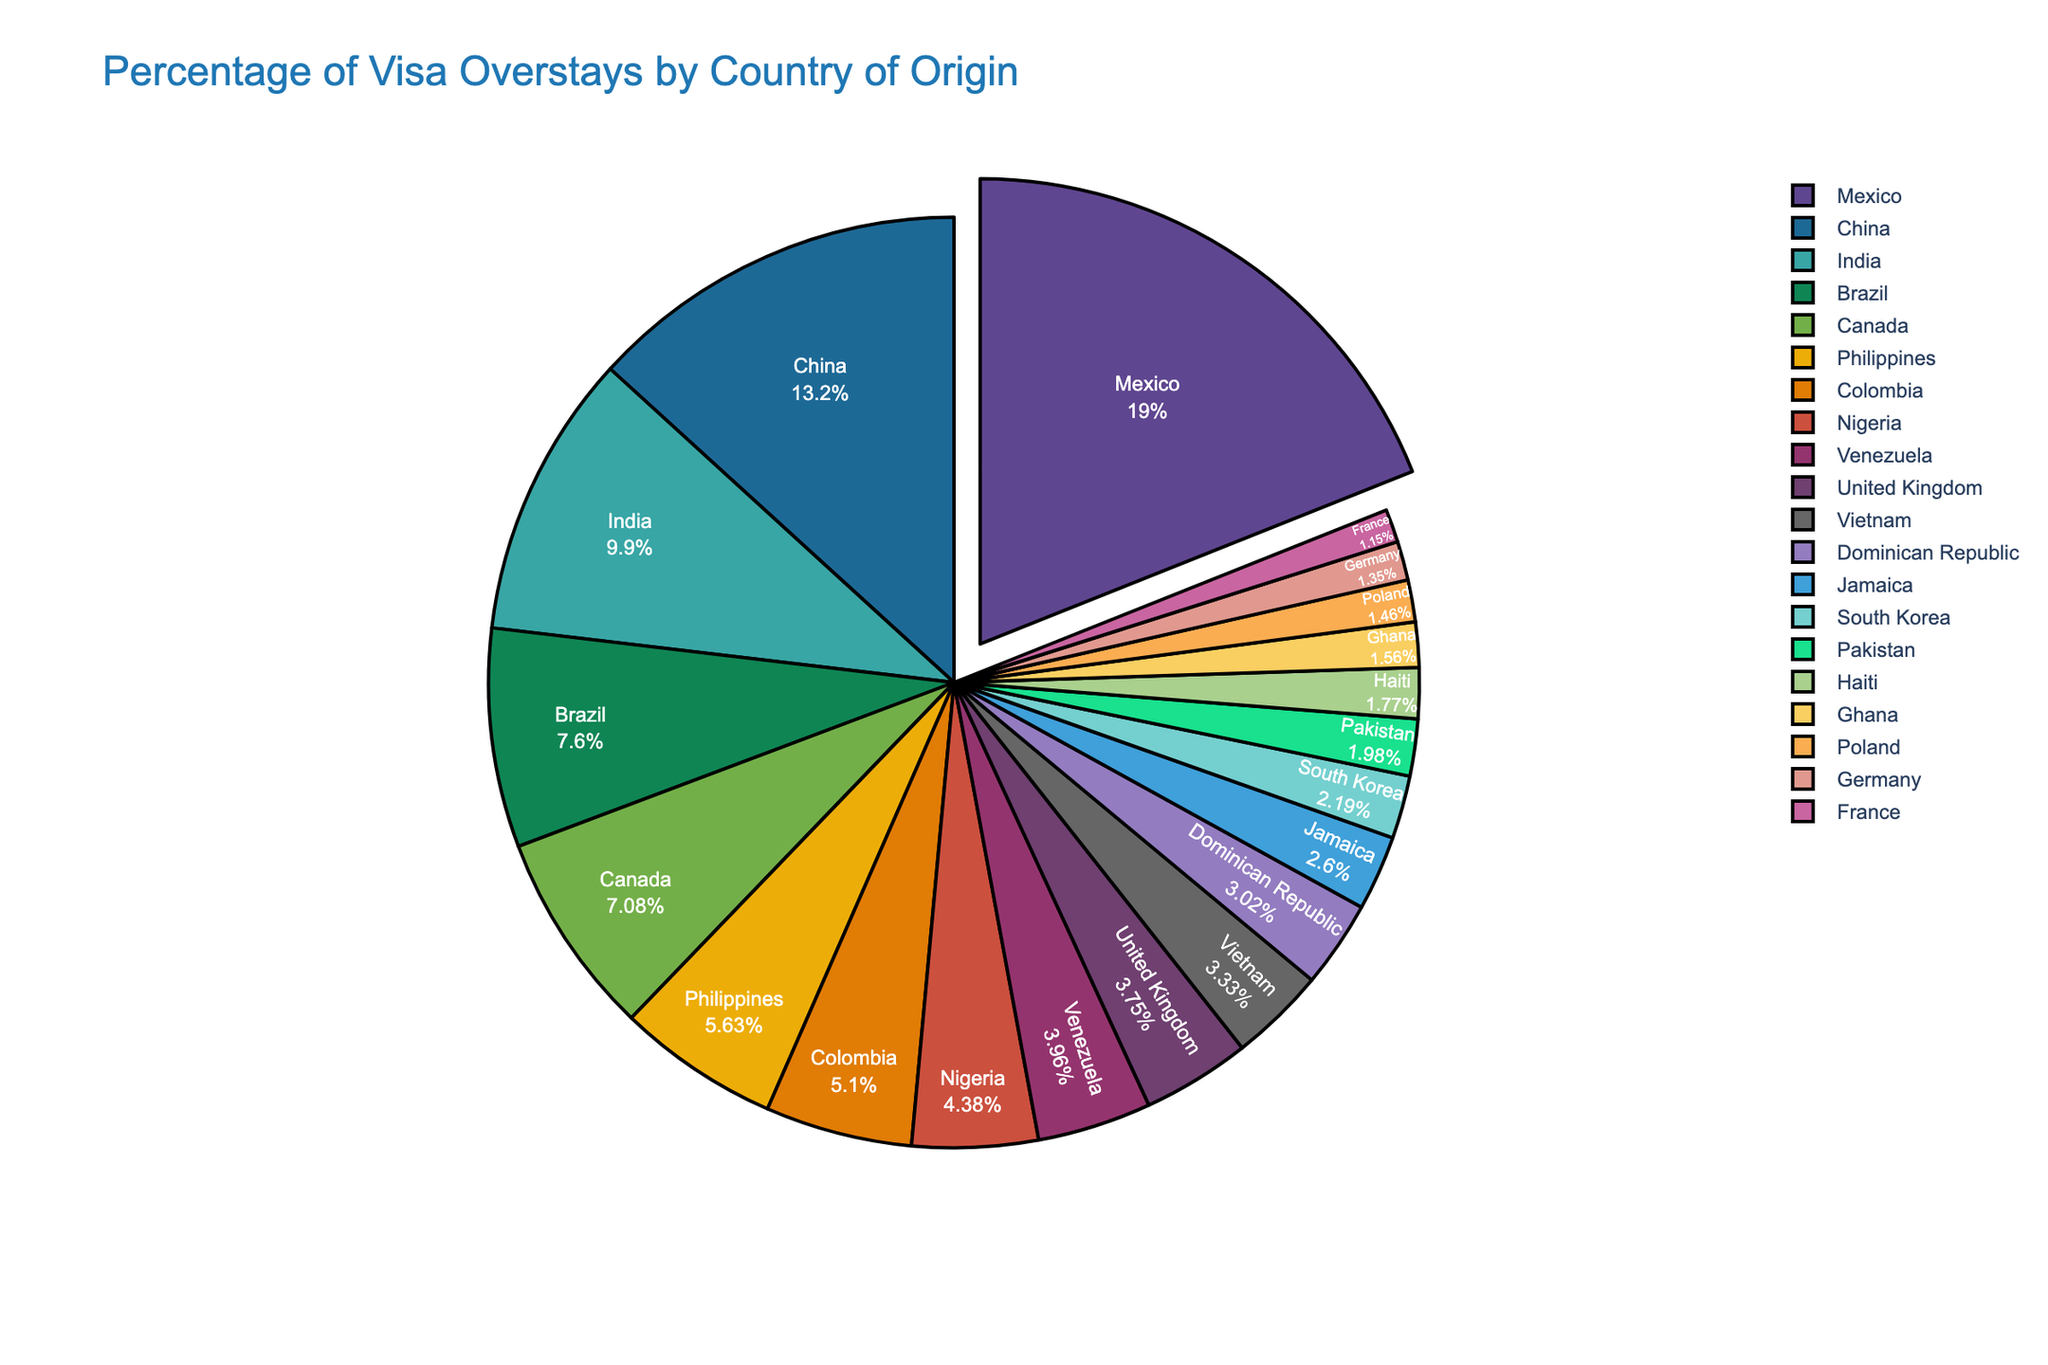What country has the highest percentage of visa overstays? By examining the pie chart, we see that Mexico has the largest segment, and its percentage is 18.2%, the highest among all countries.
Answer: Mexico Which countries have a percentage of visa overstays less than 5%? By looking at the pie chart, we identify the smaller segments and their labels. The countries with a percentage of visa overstays less than 5% are Colombia, Nigeria, Venezuela, United Kingdom, Vietnam, Dominican Republic, Jamaica, South Korea, Pakistan, Haiti, Ghana, Poland, Germany, and France.
Answer: Colombia, Nigeria, Venezuela, United Kingdom, Vietnam, Dominican Republic, Jamaica, South Korea, Pakistan, Haiti, Ghana, Poland, Germany, France What is the combined percentage of visa overstays for China and India? Add the percentages for China (12.7%) and India (9.5%). The combined percentage is 12.7 + 9.5 = 22.2%.
Answer: 22.2% Are there more visa overstays from Canada or Brazil? By comparing the segments representing Canada and Brazil, we see that Brazil has 7.3%, and Canada has 6.8%. Brazil has a higher percentage of visa overstays than Canada.
Answer: Brazil How much smaller is the percentage of visa overstays from the Philippines compared to Mexico? Subtract the percentage of the Philippines (5.4%) from Mexico (18.2%). The result is 18.2 - 5.4 = 12.8%.
Answer: 12.8% Which country has the 4th highest percentage of visa overstays? By examining the segments in descending order, the 4th largest segment is Brazil, which has 7.3%.
Answer: Brazil What is the total percentage of visa overstays for the countries with less than 2% each? Summing the percentages of countries with less than 2%, we get Pakistan (1.9%), Haiti (1.7%), Ghana (1.5%), Poland (1.4%), Germany (1.3%), and France (1.1%). The total is 1.9 + 1.7 + 1.5 + 1.4 + 1.3 + 1.1 = 8.9%.
Answer: 8.9% Which country has a smaller visa overstay percentage, Vietnam or the Dominican Republic? By comparing the segments for Vietnam and the Dominican Republic, we see that Vietnam has 3.2%, and the Dominican Republic has 2.9%. The Dominican Republic has a smaller percentage.
Answer: Dominican Republic Combining visa overstays from the United Kingdom, Vietnam, and France, does the total exceed that of the Philippines? Add the percentages of the United Kingdom (3.6%), Vietnam (3.2%), and France (1.1%) to get 3.6 + 3.2 + 1.1 = 7.9%. Comparing this with the Philippines (5.4%), the combined total does exceed that of the Philippines.
Answer: Yes, 7.9% > 5.4% 